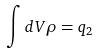<formula> <loc_0><loc_0><loc_500><loc_500>\int d V \rho = q _ { 2 }</formula> 